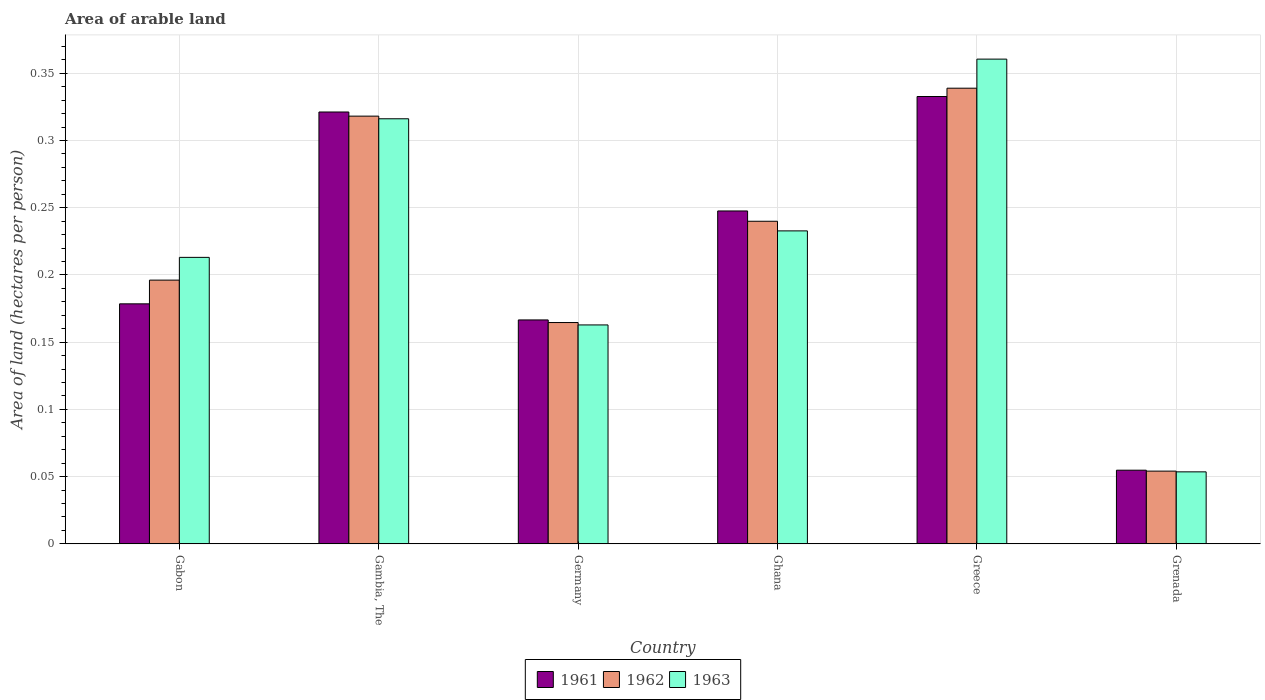Are the number of bars on each tick of the X-axis equal?
Offer a terse response. Yes. How many bars are there on the 4th tick from the right?
Keep it short and to the point. 3. What is the label of the 4th group of bars from the left?
Make the answer very short. Ghana. What is the total arable land in 1963 in Gabon?
Provide a succinct answer. 0.21. Across all countries, what is the maximum total arable land in 1961?
Your answer should be compact. 0.33. Across all countries, what is the minimum total arable land in 1963?
Keep it short and to the point. 0.05. In which country was the total arable land in 1961 minimum?
Your answer should be very brief. Grenada. What is the total total arable land in 1961 in the graph?
Provide a succinct answer. 1.3. What is the difference between the total arable land in 1962 in Gabon and that in Gambia, The?
Ensure brevity in your answer.  -0.12. What is the difference between the total arable land in 1963 in Gambia, The and the total arable land in 1961 in Ghana?
Ensure brevity in your answer.  0.07. What is the average total arable land in 1963 per country?
Make the answer very short. 0.22. What is the difference between the total arable land of/in 1963 and total arable land of/in 1961 in Greece?
Keep it short and to the point. 0.03. In how many countries, is the total arable land in 1962 greater than 0.16000000000000003 hectares per person?
Give a very brief answer. 5. What is the ratio of the total arable land in 1961 in Gabon to that in Greece?
Your response must be concise. 0.54. What is the difference between the highest and the second highest total arable land in 1962?
Ensure brevity in your answer.  0.1. What is the difference between the highest and the lowest total arable land in 1962?
Give a very brief answer. 0.28. In how many countries, is the total arable land in 1962 greater than the average total arable land in 1962 taken over all countries?
Provide a succinct answer. 3. What does the 3rd bar from the left in Gabon represents?
Offer a very short reply. 1963. What does the 2nd bar from the right in Greece represents?
Your answer should be very brief. 1962. Is it the case that in every country, the sum of the total arable land in 1961 and total arable land in 1962 is greater than the total arable land in 1963?
Offer a terse response. Yes. Are all the bars in the graph horizontal?
Your response must be concise. No. What is the difference between two consecutive major ticks on the Y-axis?
Keep it short and to the point. 0.05. Does the graph contain grids?
Your answer should be compact. Yes. Where does the legend appear in the graph?
Your answer should be compact. Bottom center. How are the legend labels stacked?
Provide a short and direct response. Horizontal. What is the title of the graph?
Provide a short and direct response. Area of arable land. What is the label or title of the Y-axis?
Your answer should be very brief. Area of land (hectares per person). What is the Area of land (hectares per person) of 1961 in Gabon?
Provide a short and direct response. 0.18. What is the Area of land (hectares per person) in 1962 in Gabon?
Give a very brief answer. 0.2. What is the Area of land (hectares per person) in 1963 in Gabon?
Make the answer very short. 0.21. What is the Area of land (hectares per person) in 1961 in Gambia, The?
Give a very brief answer. 0.32. What is the Area of land (hectares per person) in 1962 in Gambia, The?
Provide a succinct answer. 0.32. What is the Area of land (hectares per person) in 1963 in Gambia, The?
Your response must be concise. 0.32. What is the Area of land (hectares per person) in 1961 in Germany?
Your response must be concise. 0.17. What is the Area of land (hectares per person) of 1962 in Germany?
Keep it short and to the point. 0.16. What is the Area of land (hectares per person) of 1963 in Germany?
Keep it short and to the point. 0.16. What is the Area of land (hectares per person) in 1961 in Ghana?
Your response must be concise. 0.25. What is the Area of land (hectares per person) in 1962 in Ghana?
Ensure brevity in your answer.  0.24. What is the Area of land (hectares per person) in 1963 in Ghana?
Your answer should be compact. 0.23. What is the Area of land (hectares per person) in 1961 in Greece?
Ensure brevity in your answer.  0.33. What is the Area of land (hectares per person) of 1962 in Greece?
Your answer should be compact. 0.34. What is the Area of land (hectares per person) of 1963 in Greece?
Keep it short and to the point. 0.36. What is the Area of land (hectares per person) in 1961 in Grenada?
Offer a very short reply. 0.05. What is the Area of land (hectares per person) in 1962 in Grenada?
Offer a very short reply. 0.05. What is the Area of land (hectares per person) in 1963 in Grenada?
Give a very brief answer. 0.05. Across all countries, what is the maximum Area of land (hectares per person) in 1961?
Provide a succinct answer. 0.33. Across all countries, what is the maximum Area of land (hectares per person) in 1962?
Your answer should be very brief. 0.34. Across all countries, what is the maximum Area of land (hectares per person) of 1963?
Keep it short and to the point. 0.36. Across all countries, what is the minimum Area of land (hectares per person) of 1961?
Offer a very short reply. 0.05. Across all countries, what is the minimum Area of land (hectares per person) of 1962?
Provide a short and direct response. 0.05. Across all countries, what is the minimum Area of land (hectares per person) in 1963?
Provide a short and direct response. 0.05. What is the total Area of land (hectares per person) in 1961 in the graph?
Your answer should be very brief. 1.3. What is the total Area of land (hectares per person) of 1962 in the graph?
Provide a succinct answer. 1.31. What is the total Area of land (hectares per person) in 1963 in the graph?
Your answer should be compact. 1.34. What is the difference between the Area of land (hectares per person) of 1961 in Gabon and that in Gambia, The?
Offer a very short reply. -0.14. What is the difference between the Area of land (hectares per person) of 1962 in Gabon and that in Gambia, The?
Keep it short and to the point. -0.12. What is the difference between the Area of land (hectares per person) of 1963 in Gabon and that in Gambia, The?
Offer a very short reply. -0.1. What is the difference between the Area of land (hectares per person) of 1961 in Gabon and that in Germany?
Offer a very short reply. 0.01. What is the difference between the Area of land (hectares per person) of 1962 in Gabon and that in Germany?
Your answer should be very brief. 0.03. What is the difference between the Area of land (hectares per person) in 1963 in Gabon and that in Germany?
Keep it short and to the point. 0.05. What is the difference between the Area of land (hectares per person) of 1961 in Gabon and that in Ghana?
Keep it short and to the point. -0.07. What is the difference between the Area of land (hectares per person) in 1962 in Gabon and that in Ghana?
Your answer should be compact. -0.04. What is the difference between the Area of land (hectares per person) in 1963 in Gabon and that in Ghana?
Provide a short and direct response. -0.02. What is the difference between the Area of land (hectares per person) of 1961 in Gabon and that in Greece?
Ensure brevity in your answer.  -0.15. What is the difference between the Area of land (hectares per person) in 1962 in Gabon and that in Greece?
Your answer should be compact. -0.14. What is the difference between the Area of land (hectares per person) in 1963 in Gabon and that in Greece?
Provide a succinct answer. -0.15. What is the difference between the Area of land (hectares per person) in 1961 in Gabon and that in Grenada?
Keep it short and to the point. 0.12. What is the difference between the Area of land (hectares per person) of 1962 in Gabon and that in Grenada?
Make the answer very short. 0.14. What is the difference between the Area of land (hectares per person) in 1963 in Gabon and that in Grenada?
Your answer should be compact. 0.16. What is the difference between the Area of land (hectares per person) in 1961 in Gambia, The and that in Germany?
Offer a terse response. 0.15. What is the difference between the Area of land (hectares per person) of 1962 in Gambia, The and that in Germany?
Offer a very short reply. 0.15. What is the difference between the Area of land (hectares per person) of 1963 in Gambia, The and that in Germany?
Ensure brevity in your answer.  0.15. What is the difference between the Area of land (hectares per person) of 1961 in Gambia, The and that in Ghana?
Provide a short and direct response. 0.07. What is the difference between the Area of land (hectares per person) of 1962 in Gambia, The and that in Ghana?
Make the answer very short. 0.08. What is the difference between the Area of land (hectares per person) of 1963 in Gambia, The and that in Ghana?
Provide a succinct answer. 0.08. What is the difference between the Area of land (hectares per person) in 1961 in Gambia, The and that in Greece?
Give a very brief answer. -0.01. What is the difference between the Area of land (hectares per person) of 1962 in Gambia, The and that in Greece?
Your answer should be very brief. -0.02. What is the difference between the Area of land (hectares per person) in 1963 in Gambia, The and that in Greece?
Your answer should be compact. -0.04. What is the difference between the Area of land (hectares per person) of 1961 in Gambia, The and that in Grenada?
Your response must be concise. 0.27. What is the difference between the Area of land (hectares per person) in 1962 in Gambia, The and that in Grenada?
Provide a short and direct response. 0.26. What is the difference between the Area of land (hectares per person) of 1963 in Gambia, The and that in Grenada?
Offer a terse response. 0.26. What is the difference between the Area of land (hectares per person) of 1961 in Germany and that in Ghana?
Provide a short and direct response. -0.08. What is the difference between the Area of land (hectares per person) of 1962 in Germany and that in Ghana?
Your answer should be very brief. -0.08. What is the difference between the Area of land (hectares per person) in 1963 in Germany and that in Ghana?
Provide a short and direct response. -0.07. What is the difference between the Area of land (hectares per person) in 1961 in Germany and that in Greece?
Offer a very short reply. -0.17. What is the difference between the Area of land (hectares per person) in 1962 in Germany and that in Greece?
Provide a short and direct response. -0.17. What is the difference between the Area of land (hectares per person) in 1963 in Germany and that in Greece?
Provide a succinct answer. -0.2. What is the difference between the Area of land (hectares per person) of 1961 in Germany and that in Grenada?
Make the answer very short. 0.11. What is the difference between the Area of land (hectares per person) in 1962 in Germany and that in Grenada?
Offer a terse response. 0.11. What is the difference between the Area of land (hectares per person) of 1963 in Germany and that in Grenada?
Your answer should be compact. 0.11. What is the difference between the Area of land (hectares per person) of 1961 in Ghana and that in Greece?
Your response must be concise. -0.09. What is the difference between the Area of land (hectares per person) in 1962 in Ghana and that in Greece?
Give a very brief answer. -0.1. What is the difference between the Area of land (hectares per person) of 1963 in Ghana and that in Greece?
Your response must be concise. -0.13. What is the difference between the Area of land (hectares per person) of 1961 in Ghana and that in Grenada?
Offer a terse response. 0.19. What is the difference between the Area of land (hectares per person) of 1962 in Ghana and that in Grenada?
Ensure brevity in your answer.  0.19. What is the difference between the Area of land (hectares per person) of 1963 in Ghana and that in Grenada?
Give a very brief answer. 0.18. What is the difference between the Area of land (hectares per person) of 1961 in Greece and that in Grenada?
Your response must be concise. 0.28. What is the difference between the Area of land (hectares per person) in 1962 in Greece and that in Grenada?
Ensure brevity in your answer.  0.28. What is the difference between the Area of land (hectares per person) of 1963 in Greece and that in Grenada?
Your answer should be compact. 0.31. What is the difference between the Area of land (hectares per person) in 1961 in Gabon and the Area of land (hectares per person) in 1962 in Gambia, The?
Give a very brief answer. -0.14. What is the difference between the Area of land (hectares per person) in 1961 in Gabon and the Area of land (hectares per person) in 1963 in Gambia, The?
Keep it short and to the point. -0.14. What is the difference between the Area of land (hectares per person) of 1962 in Gabon and the Area of land (hectares per person) of 1963 in Gambia, The?
Your answer should be compact. -0.12. What is the difference between the Area of land (hectares per person) of 1961 in Gabon and the Area of land (hectares per person) of 1962 in Germany?
Your answer should be very brief. 0.01. What is the difference between the Area of land (hectares per person) of 1961 in Gabon and the Area of land (hectares per person) of 1963 in Germany?
Provide a succinct answer. 0.02. What is the difference between the Area of land (hectares per person) in 1962 in Gabon and the Area of land (hectares per person) in 1963 in Germany?
Provide a succinct answer. 0.03. What is the difference between the Area of land (hectares per person) in 1961 in Gabon and the Area of land (hectares per person) in 1962 in Ghana?
Your answer should be compact. -0.06. What is the difference between the Area of land (hectares per person) of 1961 in Gabon and the Area of land (hectares per person) of 1963 in Ghana?
Your response must be concise. -0.05. What is the difference between the Area of land (hectares per person) of 1962 in Gabon and the Area of land (hectares per person) of 1963 in Ghana?
Provide a succinct answer. -0.04. What is the difference between the Area of land (hectares per person) of 1961 in Gabon and the Area of land (hectares per person) of 1962 in Greece?
Offer a terse response. -0.16. What is the difference between the Area of land (hectares per person) of 1961 in Gabon and the Area of land (hectares per person) of 1963 in Greece?
Give a very brief answer. -0.18. What is the difference between the Area of land (hectares per person) of 1962 in Gabon and the Area of land (hectares per person) of 1963 in Greece?
Your answer should be very brief. -0.16. What is the difference between the Area of land (hectares per person) in 1961 in Gabon and the Area of land (hectares per person) in 1962 in Grenada?
Keep it short and to the point. 0.12. What is the difference between the Area of land (hectares per person) of 1961 in Gabon and the Area of land (hectares per person) of 1963 in Grenada?
Ensure brevity in your answer.  0.12. What is the difference between the Area of land (hectares per person) in 1962 in Gabon and the Area of land (hectares per person) in 1963 in Grenada?
Offer a terse response. 0.14. What is the difference between the Area of land (hectares per person) in 1961 in Gambia, The and the Area of land (hectares per person) in 1962 in Germany?
Your answer should be compact. 0.16. What is the difference between the Area of land (hectares per person) in 1961 in Gambia, The and the Area of land (hectares per person) in 1963 in Germany?
Give a very brief answer. 0.16. What is the difference between the Area of land (hectares per person) of 1962 in Gambia, The and the Area of land (hectares per person) of 1963 in Germany?
Provide a short and direct response. 0.16. What is the difference between the Area of land (hectares per person) of 1961 in Gambia, The and the Area of land (hectares per person) of 1962 in Ghana?
Offer a very short reply. 0.08. What is the difference between the Area of land (hectares per person) in 1961 in Gambia, The and the Area of land (hectares per person) in 1963 in Ghana?
Your response must be concise. 0.09. What is the difference between the Area of land (hectares per person) of 1962 in Gambia, The and the Area of land (hectares per person) of 1963 in Ghana?
Your answer should be compact. 0.09. What is the difference between the Area of land (hectares per person) of 1961 in Gambia, The and the Area of land (hectares per person) of 1962 in Greece?
Provide a short and direct response. -0.02. What is the difference between the Area of land (hectares per person) in 1961 in Gambia, The and the Area of land (hectares per person) in 1963 in Greece?
Your answer should be compact. -0.04. What is the difference between the Area of land (hectares per person) in 1962 in Gambia, The and the Area of land (hectares per person) in 1963 in Greece?
Your response must be concise. -0.04. What is the difference between the Area of land (hectares per person) in 1961 in Gambia, The and the Area of land (hectares per person) in 1962 in Grenada?
Offer a terse response. 0.27. What is the difference between the Area of land (hectares per person) of 1961 in Gambia, The and the Area of land (hectares per person) of 1963 in Grenada?
Your response must be concise. 0.27. What is the difference between the Area of land (hectares per person) of 1962 in Gambia, The and the Area of land (hectares per person) of 1963 in Grenada?
Ensure brevity in your answer.  0.26. What is the difference between the Area of land (hectares per person) of 1961 in Germany and the Area of land (hectares per person) of 1962 in Ghana?
Your response must be concise. -0.07. What is the difference between the Area of land (hectares per person) in 1961 in Germany and the Area of land (hectares per person) in 1963 in Ghana?
Provide a succinct answer. -0.07. What is the difference between the Area of land (hectares per person) of 1962 in Germany and the Area of land (hectares per person) of 1963 in Ghana?
Offer a terse response. -0.07. What is the difference between the Area of land (hectares per person) in 1961 in Germany and the Area of land (hectares per person) in 1962 in Greece?
Ensure brevity in your answer.  -0.17. What is the difference between the Area of land (hectares per person) of 1961 in Germany and the Area of land (hectares per person) of 1963 in Greece?
Make the answer very short. -0.19. What is the difference between the Area of land (hectares per person) of 1962 in Germany and the Area of land (hectares per person) of 1963 in Greece?
Provide a succinct answer. -0.2. What is the difference between the Area of land (hectares per person) in 1961 in Germany and the Area of land (hectares per person) in 1962 in Grenada?
Provide a succinct answer. 0.11. What is the difference between the Area of land (hectares per person) of 1961 in Germany and the Area of land (hectares per person) of 1963 in Grenada?
Your response must be concise. 0.11. What is the difference between the Area of land (hectares per person) in 1962 in Germany and the Area of land (hectares per person) in 1963 in Grenada?
Provide a succinct answer. 0.11. What is the difference between the Area of land (hectares per person) in 1961 in Ghana and the Area of land (hectares per person) in 1962 in Greece?
Keep it short and to the point. -0.09. What is the difference between the Area of land (hectares per person) of 1961 in Ghana and the Area of land (hectares per person) of 1963 in Greece?
Ensure brevity in your answer.  -0.11. What is the difference between the Area of land (hectares per person) of 1962 in Ghana and the Area of land (hectares per person) of 1963 in Greece?
Offer a terse response. -0.12. What is the difference between the Area of land (hectares per person) of 1961 in Ghana and the Area of land (hectares per person) of 1962 in Grenada?
Your answer should be compact. 0.19. What is the difference between the Area of land (hectares per person) in 1961 in Ghana and the Area of land (hectares per person) in 1963 in Grenada?
Keep it short and to the point. 0.19. What is the difference between the Area of land (hectares per person) in 1962 in Ghana and the Area of land (hectares per person) in 1963 in Grenada?
Your response must be concise. 0.19. What is the difference between the Area of land (hectares per person) in 1961 in Greece and the Area of land (hectares per person) in 1962 in Grenada?
Your response must be concise. 0.28. What is the difference between the Area of land (hectares per person) of 1961 in Greece and the Area of land (hectares per person) of 1963 in Grenada?
Make the answer very short. 0.28. What is the difference between the Area of land (hectares per person) in 1962 in Greece and the Area of land (hectares per person) in 1963 in Grenada?
Make the answer very short. 0.29. What is the average Area of land (hectares per person) in 1961 per country?
Keep it short and to the point. 0.22. What is the average Area of land (hectares per person) of 1962 per country?
Keep it short and to the point. 0.22. What is the average Area of land (hectares per person) in 1963 per country?
Ensure brevity in your answer.  0.22. What is the difference between the Area of land (hectares per person) of 1961 and Area of land (hectares per person) of 1962 in Gabon?
Your answer should be very brief. -0.02. What is the difference between the Area of land (hectares per person) of 1961 and Area of land (hectares per person) of 1963 in Gabon?
Ensure brevity in your answer.  -0.03. What is the difference between the Area of land (hectares per person) of 1962 and Area of land (hectares per person) of 1963 in Gabon?
Provide a short and direct response. -0.02. What is the difference between the Area of land (hectares per person) of 1961 and Area of land (hectares per person) of 1962 in Gambia, The?
Keep it short and to the point. 0. What is the difference between the Area of land (hectares per person) in 1961 and Area of land (hectares per person) in 1963 in Gambia, The?
Your answer should be compact. 0.01. What is the difference between the Area of land (hectares per person) in 1962 and Area of land (hectares per person) in 1963 in Gambia, The?
Provide a short and direct response. 0. What is the difference between the Area of land (hectares per person) in 1961 and Area of land (hectares per person) in 1962 in Germany?
Provide a succinct answer. 0. What is the difference between the Area of land (hectares per person) of 1961 and Area of land (hectares per person) of 1963 in Germany?
Offer a very short reply. 0. What is the difference between the Area of land (hectares per person) in 1962 and Area of land (hectares per person) in 1963 in Germany?
Provide a succinct answer. 0. What is the difference between the Area of land (hectares per person) of 1961 and Area of land (hectares per person) of 1962 in Ghana?
Make the answer very short. 0.01. What is the difference between the Area of land (hectares per person) in 1961 and Area of land (hectares per person) in 1963 in Ghana?
Ensure brevity in your answer.  0.01. What is the difference between the Area of land (hectares per person) of 1962 and Area of land (hectares per person) of 1963 in Ghana?
Offer a terse response. 0.01. What is the difference between the Area of land (hectares per person) in 1961 and Area of land (hectares per person) in 1962 in Greece?
Ensure brevity in your answer.  -0.01. What is the difference between the Area of land (hectares per person) in 1961 and Area of land (hectares per person) in 1963 in Greece?
Make the answer very short. -0.03. What is the difference between the Area of land (hectares per person) of 1962 and Area of land (hectares per person) of 1963 in Greece?
Your answer should be very brief. -0.02. What is the difference between the Area of land (hectares per person) in 1961 and Area of land (hectares per person) in 1962 in Grenada?
Provide a succinct answer. 0. What is the difference between the Area of land (hectares per person) of 1961 and Area of land (hectares per person) of 1963 in Grenada?
Ensure brevity in your answer.  0. What is the difference between the Area of land (hectares per person) of 1962 and Area of land (hectares per person) of 1963 in Grenada?
Your answer should be compact. 0. What is the ratio of the Area of land (hectares per person) in 1961 in Gabon to that in Gambia, The?
Your answer should be very brief. 0.56. What is the ratio of the Area of land (hectares per person) of 1962 in Gabon to that in Gambia, The?
Your answer should be very brief. 0.62. What is the ratio of the Area of land (hectares per person) of 1963 in Gabon to that in Gambia, The?
Your answer should be compact. 0.67. What is the ratio of the Area of land (hectares per person) in 1961 in Gabon to that in Germany?
Keep it short and to the point. 1.07. What is the ratio of the Area of land (hectares per person) of 1962 in Gabon to that in Germany?
Keep it short and to the point. 1.19. What is the ratio of the Area of land (hectares per person) in 1963 in Gabon to that in Germany?
Provide a short and direct response. 1.31. What is the ratio of the Area of land (hectares per person) of 1961 in Gabon to that in Ghana?
Provide a succinct answer. 0.72. What is the ratio of the Area of land (hectares per person) of 1962 in Gabon to that in Ghana?
Your answer should be compact. 0.82. What is the ratio of the Area of land (hectares per person) of 1963 in Gabon to that in Ghana?
Your answer should be very brief. 0.92. What is the ratio of the Area of land (hectares per person) in 1961 in Gabon to that in Greece?
Make the answer very short. 0.54. What is the ratio of the Area of land (hectares per person) in 1962 in Gabon to that in Greece?
Your response must be concise. 0.58. What is the ratio of the Area of land (hectares per person) of 1963 in Gabon to that in Greece?
Offer a terse response. 0.59. What is the ratio of the Area of land (hectares per person) in 1961 in Gabon to that in Grenada?
Give a very brief answer. 3.26. What is the ratio of the Area of land (hectares per person) in 1962 in Gabon to that in Grenada?
Provide a succinct answer. 3.63. What is the ratio of the Area of land (hectares per person) in 1963 in Gabon to that in Grenada?
Offer a very short reply. 3.98. What is the ratio of the Area of land (hectares per person) of 1961 in Gambia, The to that in Germany?
Provide a short and direct response. 1.93. What is the ratio of the Area of land (hectares per person) of 1962 in Gambia, The to that in Germany?
Give a very brief answer. 1.93. What is the ratio of the Area of land (hectares per person) of 1963 in Gambia, The to that in Germany?
Your answer should be compact. 1.94. What is the ratio of the Area of land (hectares per person) in 1961 in Gambia, The to that in Ghana?
Make the answer very short. 1.3. What is the ratio of the Area of land (hectares per person) in 1962 in Gambia, The to that in Ghana?
Ensure brevity in your answer.  1.33. What is the ratio of the Area of land (hectares per person) in 1963 in Gambia, The to that in Ghana?
Make the answer very short. 1.36. What is the ratio of the Area of land (hectares per person) in 1961 in Gambia, The to that in Greece?
Make the answer very short. 0.97. What is the ratio of the Area of land (hectares per person) in 1962 in Gambia, The to that in Greece?
Provide a short and direct response. 0.94. What is the ratio of the Area of land (hectares per person) in 1963 in Gambia, The to that in Greece?
Give a very brief answer. 0.88. What is the ratio of the Area of land (hectares per person) of 1961 in Gambia, The to that in Grenada?
Make the answer very short. 5.86. What is the ratio of the Area of land (hectares per person) of 1962 in Gambia, The to that in Grenada?
Keep it short and to the point. 5.88. What is the ratio of the Area of land (hectares per person) in 1963 in Gambia, The to that in Grenada?
Provide a short and direct response. 5.9. What is the ratio of the Area of land (hectares per person) of 1961 in Germany to that in Ghana?
Offer a very short reply. 0.67. What is the ratio of the Area of land (hectares per person) in 1962 in Germany to that in Ghana?
Your answer should be very brief. 0.69. What is the ratio of the Area of land (hectares per person) of 1963 in Germany to that in Ghana?
Your answer should be very brief. 0.7. What is the ratio of the Area of land (hectares per person) of 1961 in Germany to that in Greece?
Your answer should be compact. 0.5. What is the ratio of the Area of land (hectares per person) in 1962 in Germany to that in Greece?
Provide a succinct answer. 0.49. What is the ratio of the Area of land (hectares per person) of 1963 in Germany to that in Greece?
Ensure brevity in your answer.  0.45. What is the ratio of the Area of land (hectares per person) in 1961 in Germany to that in Grenada?
Your answer should be compact. 3.04. What is the ratio of the Area of land (hectares per person) of 1962 in Germany to that in Grenada?
Make the answer very short. 3.04. What is the ratio of the Area of land (hectares per person) of 1963 in Germany to that in Grenada?
Provide a short and direct response. 3.04. What is the ratio of the Area of land (hectares per person) of 1961 in Ghana to that in Greece?
Your answer should be very brief. 0.74. What is the ratio of the Area of land (hectares per person) in 1962 in Ghana to that in Greece?
Make the answer very short. 0.71. What is the ratio of the Area of land (hectares per person) of 1963 in Ghana to that in Greece?
Your response must be concise. 0.65. What is the ratio of the Area of land (hectares per person) in 1961 in Ghana to that in Grenada?
Offer a terse response. 4.52. What is the ratio of the Area of land (hectares per person) in 1962 in Ghana to that in Grenada?
Offer a terse response. 4.43. What is the ratio of the Area of land (hectares per person) of 1963 in Ghana to that in Grenada?
Keep it short and to the point. 4.35. What is the ratio of the Area of land (hectares per person) in 1961 in Greece to that in Grenada?
Offer a very short reply. 6.07. What is the ratio of the Area of land (hectares per person) of 1962 in Greece to that in Grenada?
Keep it short and to the point. 6.26. What is the ratio of the Area of land (hectares per person) of 1963 in Greece to that in Grenada?
Your response must be concise. 6.73. What is the difference between the highest and the second highest Area of land (hectares per person) of 1961?
Your answer should be compact. 0.01. What is the difference between the highest and the second highest Area of land (hectares per person) of 1962?
Provide a short and direct response. 0.02. What is the difference between the highest and the second highest Area of land (hectares per person) in 1963?
Your answer should be compact. 0.04. What is the difference between the highest and the lowest Area of land (hectares per person) in 1961?
Provide a succinct answer. 0.28. What is the difference between the highest and the lowest Area of land (hectares per person) in 1962?
Offer a terse response. 0.28. What is the difference between the highest and the lowest Area of land (hectares per person) in 1963?
Ensure brevity in your answer.  0.31. 